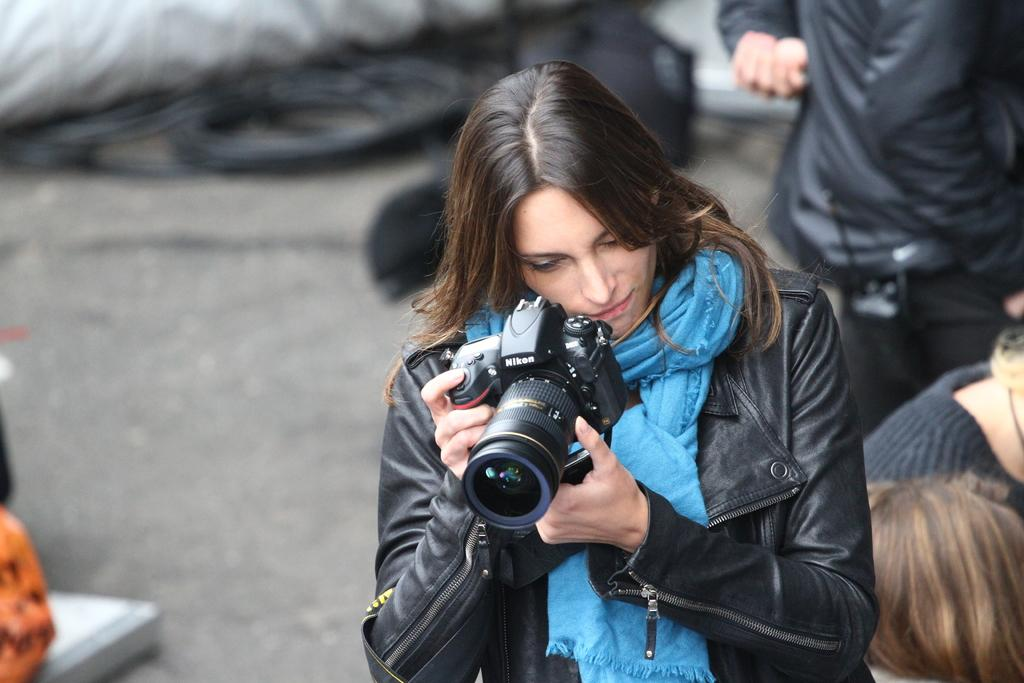Who is present in the image? There is a woman in the image. What is the woman holding in her hand? The woman is holding a camera in her hand. What type of learning material is the woman using in the image? There is no learning material present in the image; the woman is holding a camera. 